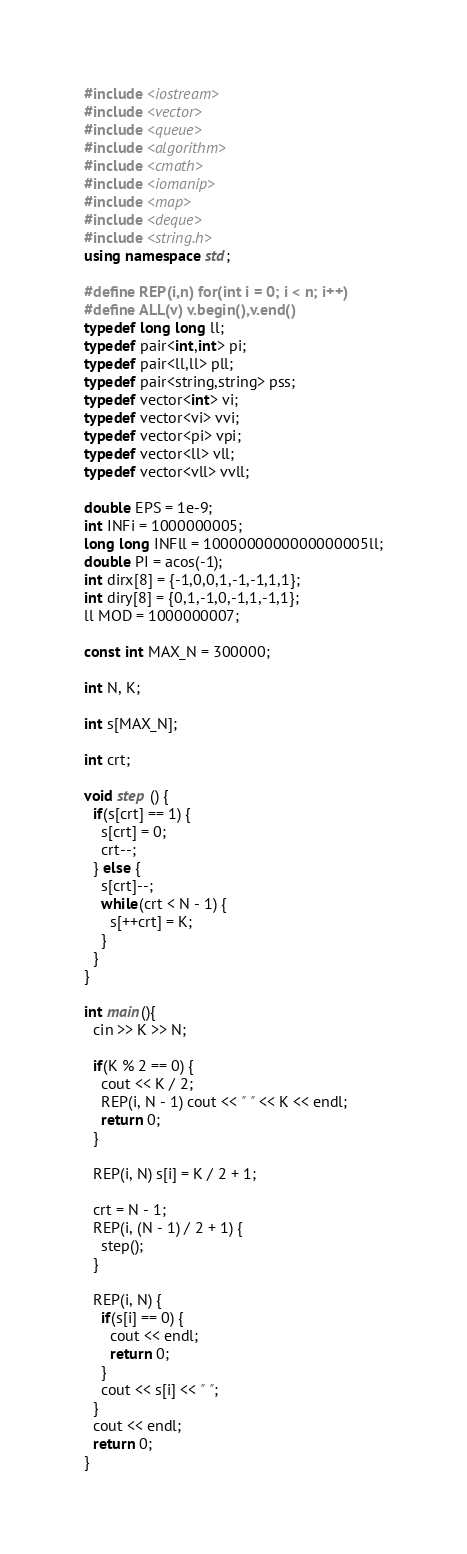Convert code to text. <code><loc_0><loc_0><loc_500><loc_500><_C++_>#include <iostream>
#include <vector>
#include <queue>
#include <algorithm>
#include <cmath>
#include <iomanip>
#include <map>
#include <deque>
#include <string.h>
using namespace std;

#define REP(i,n) for(int i = 0; i < n; i++)
#define ALL(v) v.begin(),v.end()
typedef long long ll;
typedef pair<int,int> pi;
typedef pair<ll,ll> pll;
typedef pair<string,string> pss;
typedef vector<int> vi;
typedef vector<vi> vvi;
typedef vector<pi> vpi;
typedef vector<ll> vll;
typedef vector<vll> vvll;

double EPS = 1e-9;
int INFi = 1000000005;
long long INFll = 1000000000000000005ll;
double PI = acos(-1);
int dirx[8] = {-1,0,0,1,-1,-1,1,1};
int diry[8] = {0,1,-1,0,-1,1,-1,1};
ll MOD = 1000000007;

const int MAX_N = 300000;

int N, K;

int s[MAX_N];

int crt;

void step () {
  if(s[crt] == 1) {
    s[crt] = 0;
    crt--;
  } else {
    s[crt]--;
    while(crt < N - 1) {
      s[++crt] = K;
    }
  }
}

int main(){
  cin >> K >> N;

  if(K % 2 == 0) {
    cout << K / 2;
    REP(i, N - 1) cout << " " << K << endl;
    return 0;
  }

  REP(i, N) s[i] = K / 2 + 1;

  crt = N - 1;
  REP(i, (N - 1) / 2 + 1) {
    step();
  }

  REP(i, N) {
    if(s[i] == 0) {
      cout << endl;
      return 0;
    }
    cout << s[i] << " ";
  }
  cout << endl;
  return 0;
}
</code> 